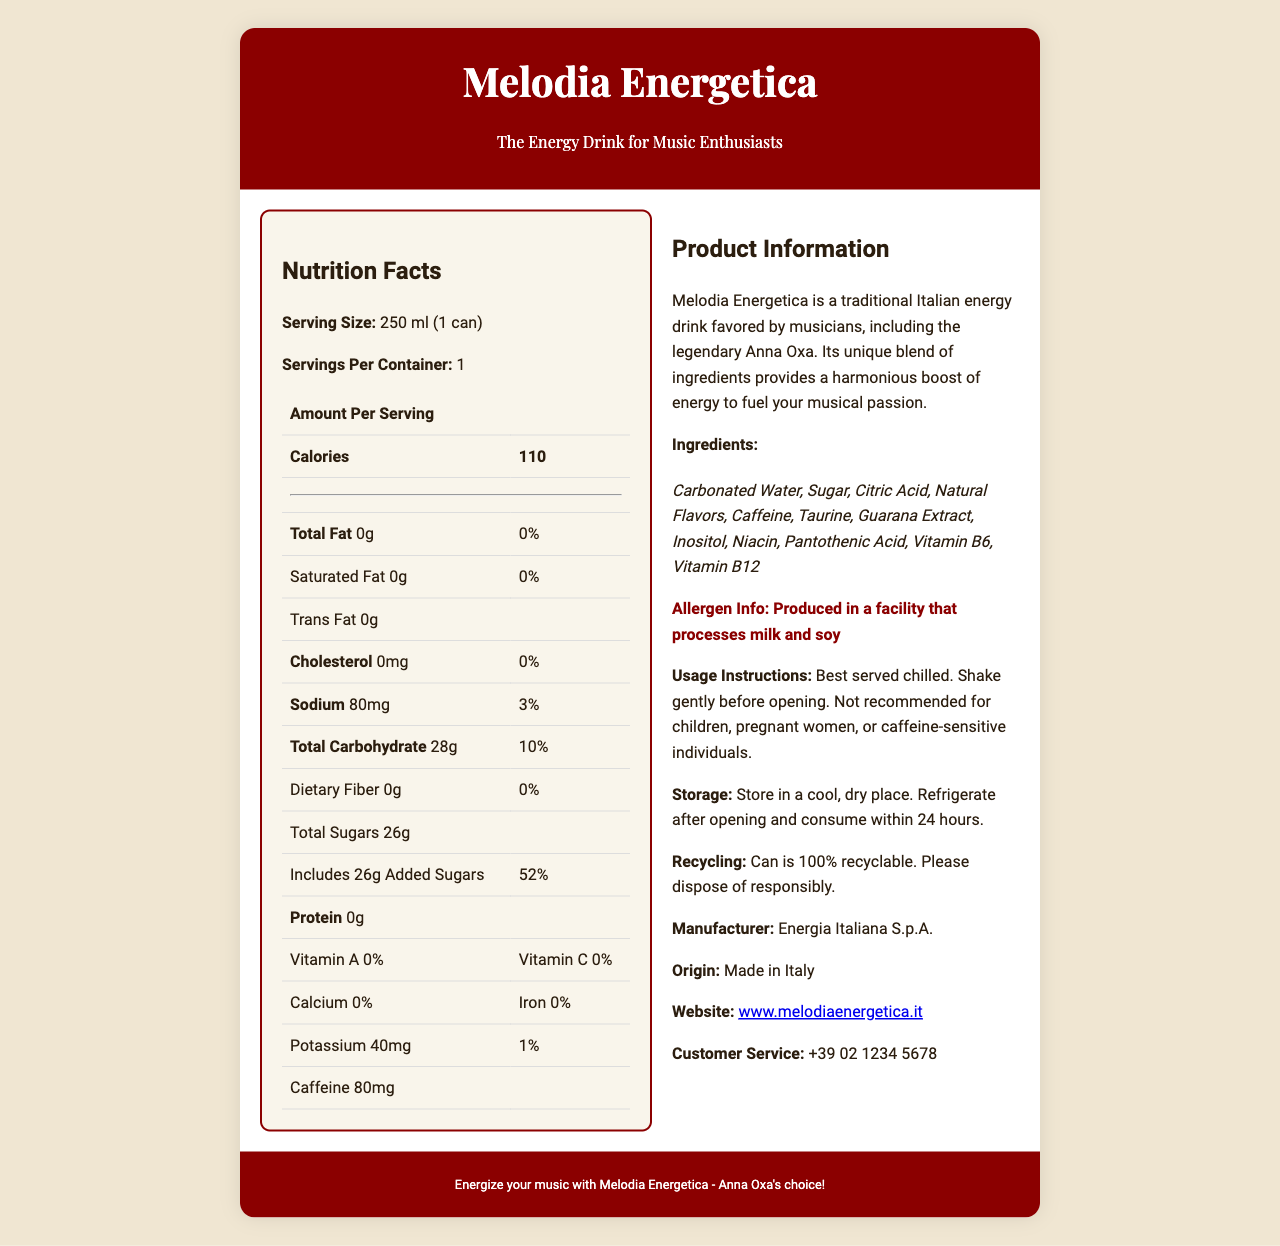what is the serving size of Melodia Energetica? The serving size is listed at the beginning of the Nutrition Facts section.
Answer: 250 ml (1 can) who manufactures Melodia Energetica? The manufacturer is specified in the product information section under the heading “Manufacturer.”
Answer: Energia Italiana S.p.A. how many calories are in one serving? The calories per serving are prominently displayed in the Amount Per Serving section of the Nutrition Facts.
Answer: 110 what is the recommended storage instruction? The storage instructions are provided under the "Storage" heading in the product information section.
Answer: Store in a cool, dry place. Refrigerate after opening and consume within 24 hours. what percentage of the daily value is the sodium content? The percentage is shown next to the sodium content in the Nutrition Facts table.
Answer: 3% which of the following ingredients are included in Melodia Energetica? A. Aspartame B. Taurine C. High Fructose Corn Syrup D. Stevia Taurine is listed in the ingredients section, while the other options are not.
Answer: B how much caffeine does one serving contain? A. 40mg B. 60mg C. 80mg D. 100mg The document states that one serving contains 80mg of caffeine, listed in the Nutrition Facts.
Answer: C is Melodia Energetica recommended for children? The usage instructions clearly state that it is not recommended for children.
Answer: No describe the entire document or the main idea. The document provides comprehensive information about the energy drink, including its nutritional profile, ingredient list, and other important consumer information.
Answer: Melodia Energetica is a traditional Italian energy drink made by Energia Italiana S.p.A. The document includes nutrition facts, ingredients, allergen information, usage instructions, storage instructions, and other product information. The drink contains 110 calories per serving and notable ingredients like Caffeine, Taurine, and Guarana Extract. It's marketed as an energy-boosting drink favored by musicians, including Anna Oxa. how much potassium is in each serving? The potassium content is listed under the Nutrition Facts table.
Answer: 40mg can I find out the production year of the drink from this document? The document does not provide any details about the production year.
Answer: Not enough information how is the can disposed of? The recycling information is mentioned in the product information section under "Recycling."
Answer: The can is 100% recyclable. Please dispose of responsibly. 